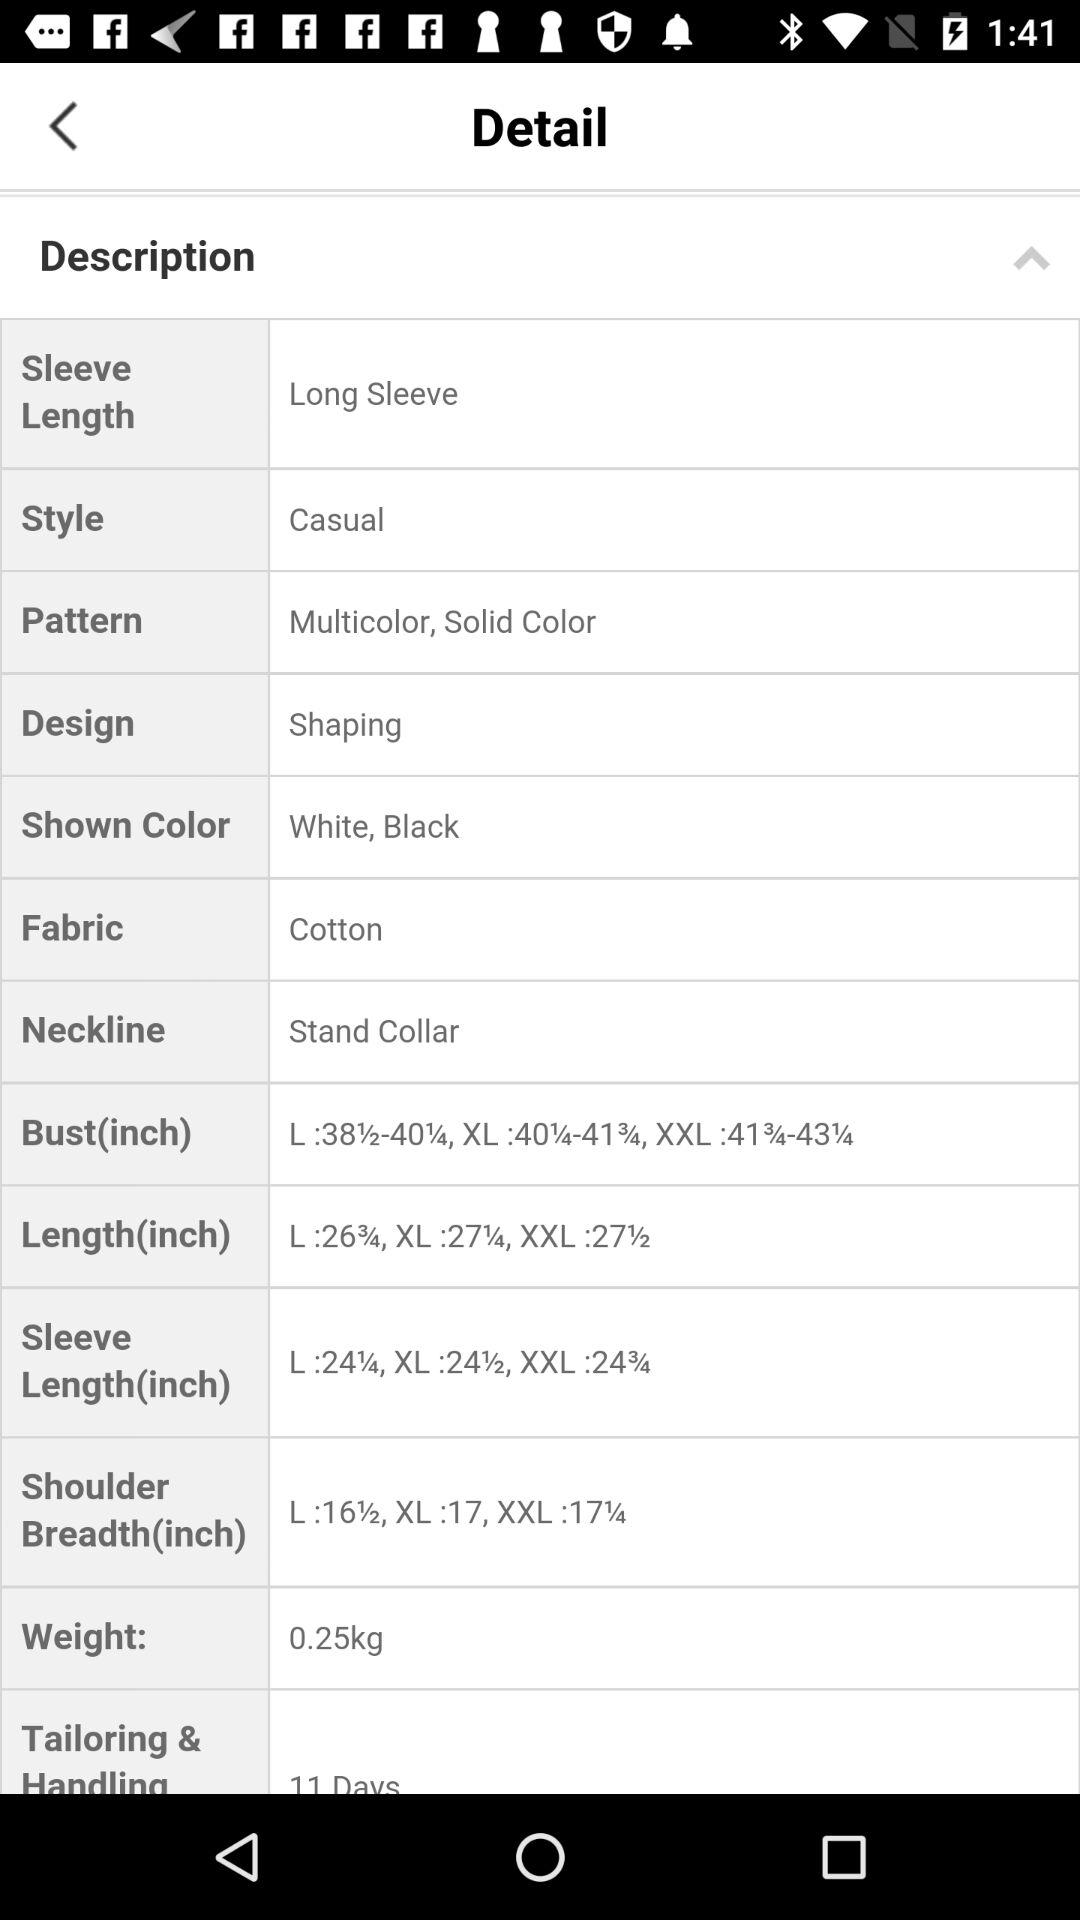What is the selected neckline? The selected neckline is a stand collar. 